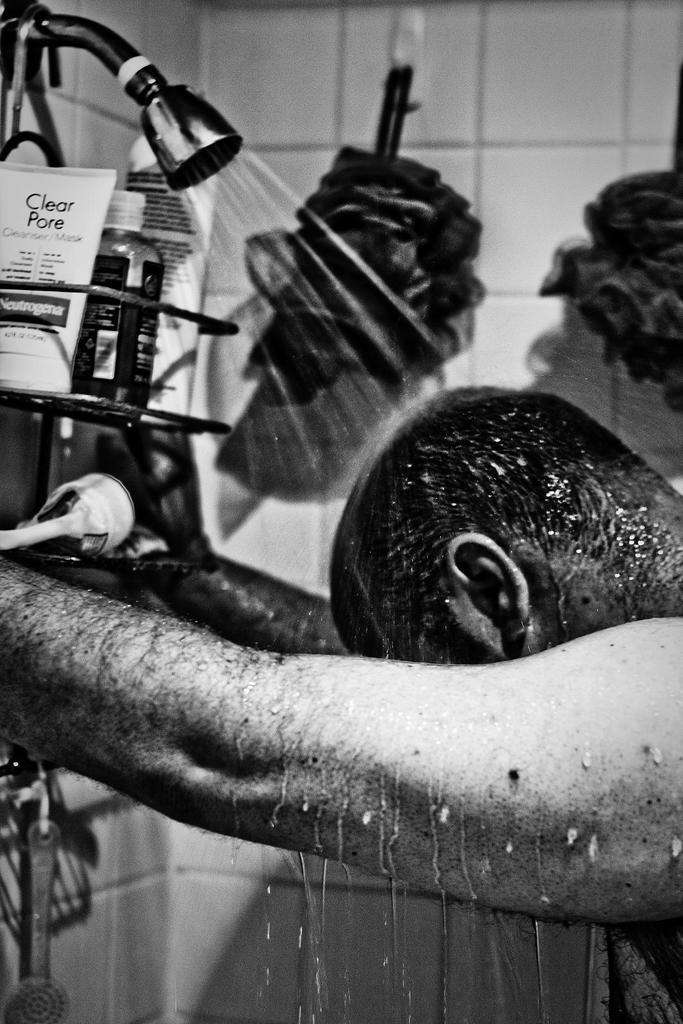Could you give a brief overview of what you see in this image? This is a black and white image and here we can see a person standing and at the top, there is a shower with water and we can see bottles and tubes on the stand and there are bath sponges hanging and there is a wall and we can see some other objects. 